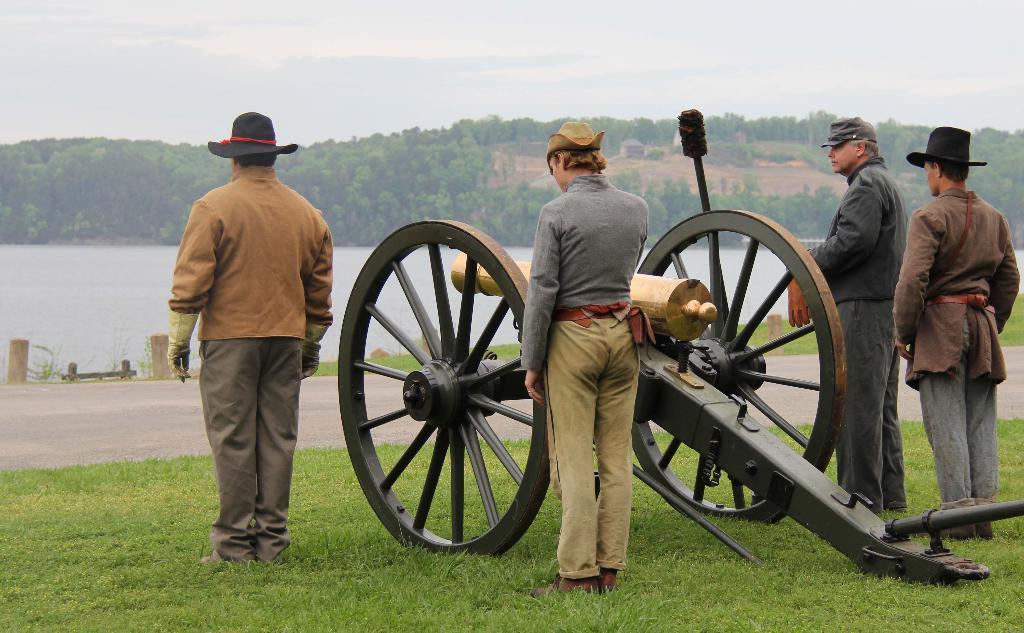Describe this image in one or two sentences. In this image there is the sky, there are trees, there is water truncated towards the left of the image, there is grass truncated towards the bottom of the image, there are four persons standing on the grass, there is a person holding an object, there is cannon on the grass, there is an object truncated towards the right of the image. 